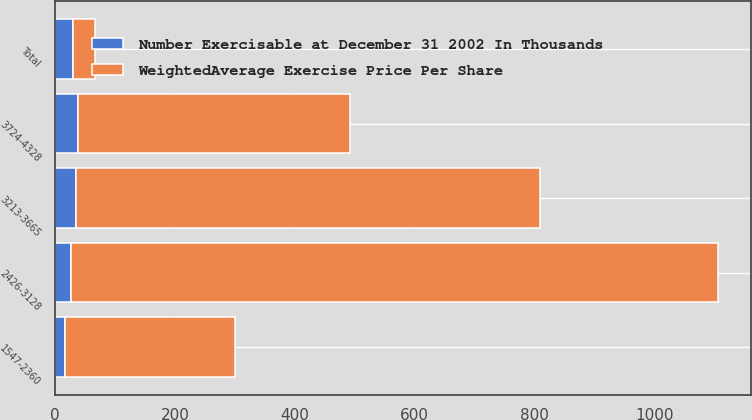<chart> <loc_0><loc_0><loc_500><loc_500><stacked_bar_chart><ecel><fcel>1547-2360<fcel>2426-3128<fcel>3213-3665<fcel>3724-4328<fcel>Total<nl><fcel>WeightedAverage Exercise Price Per Share<fcel>284<fcel>1080<fcel>775<fcel>455<fcel>37.43<nl><fcel>Number Exercisable at December 31 2002 In Thousands<fcel>16.83<fcel>25.9<fcel>34.47<fcel>37.43<fcel>29.49<nl></chart> 